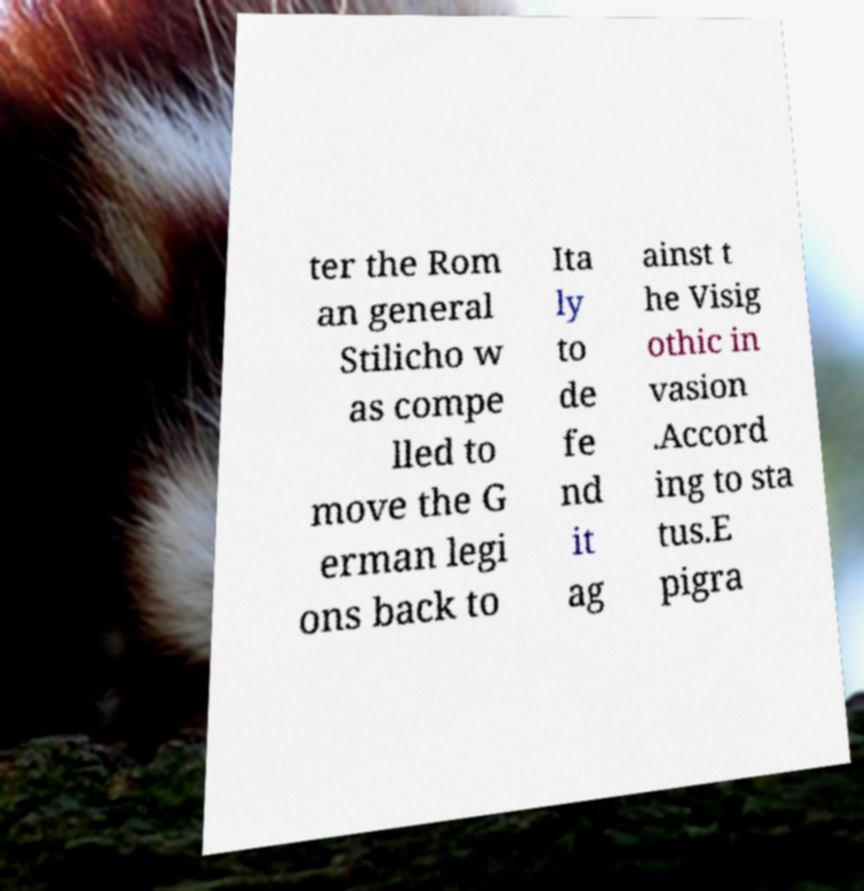What messages or text are displayed in this image? I need them in a readable, typed format. ter the Rom an general Stilicho w as compe lled to move the G erman legi ons back to Ita ly to de fe nd it ag ainst t he Visig othic in vasion .Accord ing to sta tus.E pigra 